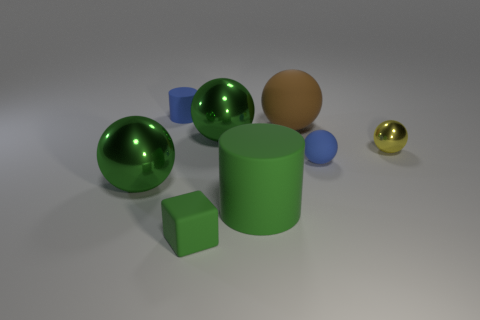Does the green sphere that is on the left side of the small green rubber cube have the same material as the large green cylinder?
Provide a short and direct response. No. How many objects are either small gray shiny objects or large green balls?
Keep it short and to the point. 2. There is a brown thing that is the same shape as the yellow thing; what size is it?
Keep it short and to the point. Large. How big is the yellow metallic ball?
Offer a terse response. Small. Is the number of tiny blue things that are on the left side of the brown thing greater than the number of green matte cylinders?
Your answer should be compact. No. Is there anything else that is made of the same material as the yellow thing?
Make the answer very short. Yes. There is a tiny matte object on the right side of the green rubber cylinder; is it the same color as the small matte thing that is behind the blue matte ball?
Offer a terse response. Yes. There is a green sphere to the right of the big metal sphere left of the tiny rubber cylinder that is behind the small cube; what is it made of?
Keep it short and to the point. Metal. Are there more large yellow matte objects than rubber cylinders?
Offer a terse response. No. Is there any other thing that has the same color as the small rubber cylinder?
Offer a terse response. Yes. 